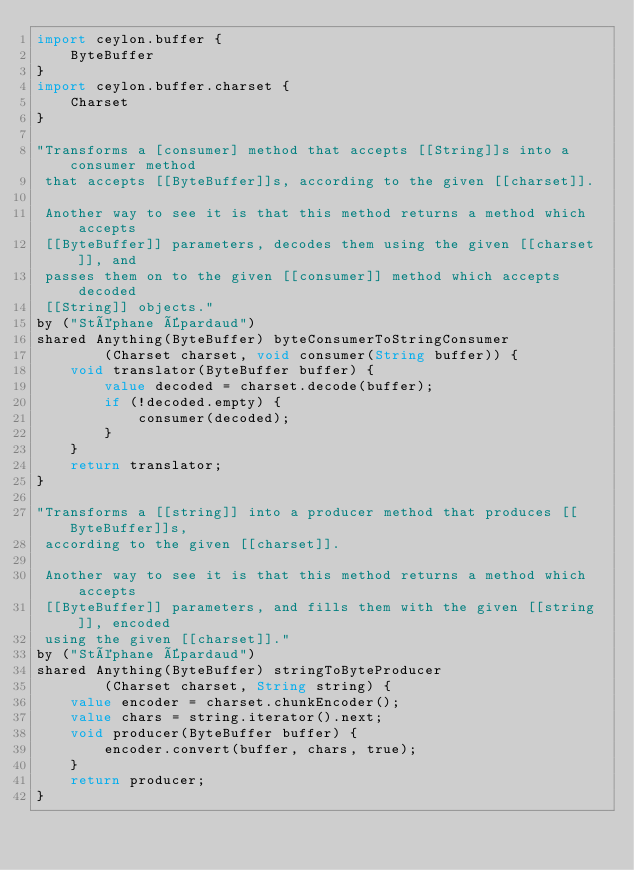<code> <loc_0><loc_0><loc_500><loc_500><_Ceylon_>import ceylon.buffer {
    ByteBuffer
}
import ceylon.buffer.charset {
    Charset
}

"Transforms a [consumer] method that accepts [[String]]s into a consumer method
 that accepts [[ByteBuffer]]s, according to the given [[charset]].
 
 Another way to see it is that this method returns a method which accepts
 [[ByteBuffer]] parameters, decodes them using the given [[charset]], and
 passes them on to the given [[consumer]] method which accepts decoded
 [[String]] objects."
by ("Stéphane Épardaud")
shared Anything(ByteBuffer) byteConsumerToStringConsumer
        (Charset charset, void consumer(String buffer)) {
    void translator(ByteBuffer buffer) {
        value decoded = charset.decode(buffer);
        if (!decoded.empty) {
            consumer(decoded);
        }
    }
    return translator;
}

"Transforms a [[string]] into a producer method that produces [[ByteBuffer]]s,
 according to the given [[charset]].
 
 Another way to see it is that this method returns a method which accepts
 [[ByteBuffer]] parameters, and fills them with the given [[string]], encoded
 using the given [[charset]]."
by ("Stéphane Épardaud")
shared Anything(ByteBuffer) stringToByteProducer
        (Charset charset, String string) {
    value encoder = charset.chunkEncoder();
    value chars = string.iterator().next;
    void producer(ByteBuffer buffer) {
        encoder.convert(buffer, chars, true);
    }
    return producer;
}
</code> 